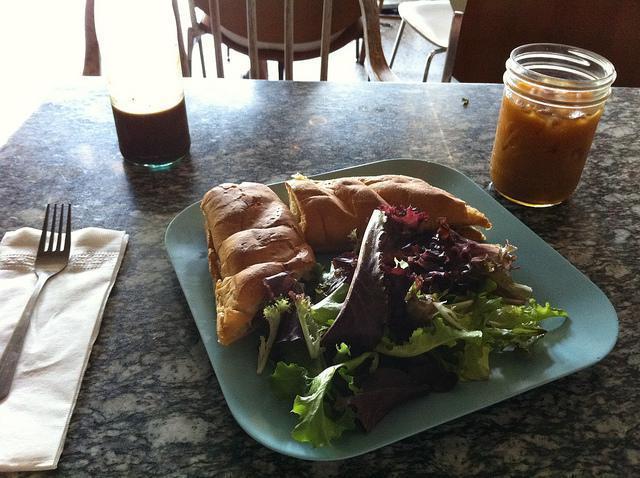How many different kinds of lettuce on the plate?
Give a very brief answer. 2. How many tines in the fork?
Give a very brief answer. 4. How many dining tables can be seen?
Give a very brief answer. 1. How many cups are in the picture?
Give a very brief answer. 2. How many giraffes are there?
Give a very brief answer. 0. 